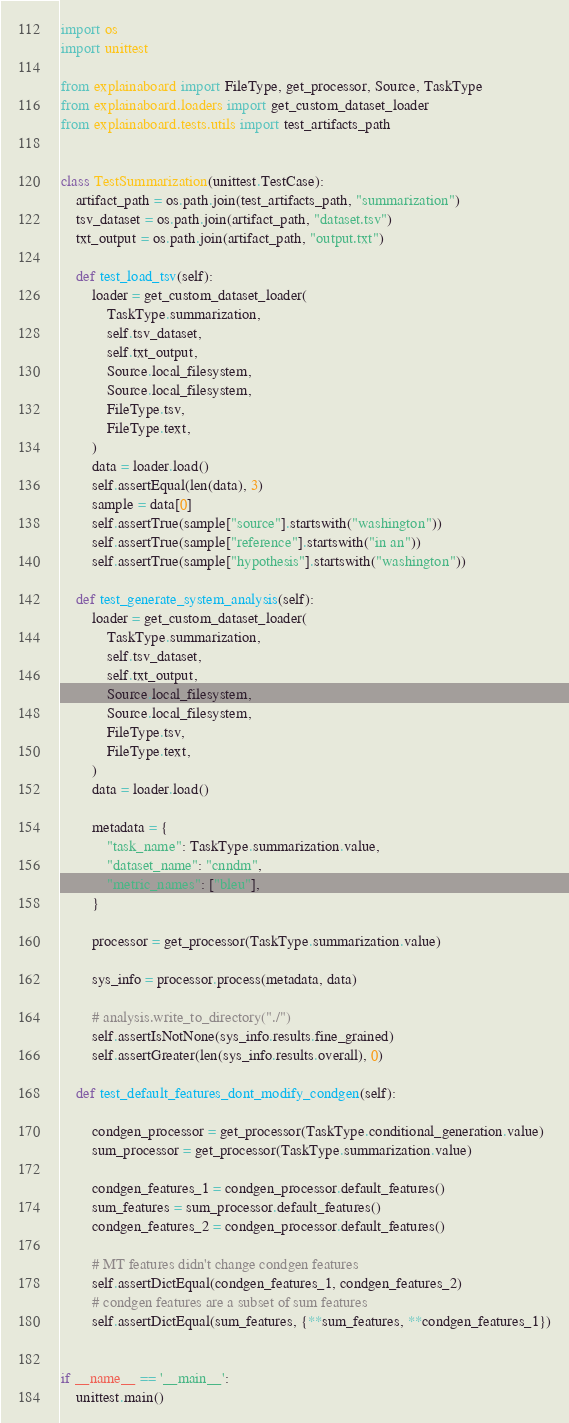Convert code to text. <code><loc_0><loc_0><loc_500><loc_500><_Python_>import os
import unittest

from explainaboard import FileType, get_processor, Source, TaskType
from explainaboard.loaders import get_custom_dataset_loader
from explainaboard.tests.utils import test_artifacts_path


class TestSummarization(unittest.TestCase):
    artifact_path = os.path.join(test_artifacts_path, "summarization")
    tsv_dataset = os.path.join(artifact_path, "dataset.tsv")
    txt_output = os.path.join(artifact_path, "output.txt")

    def test_load_tsv(self):
        loader = get_custom_dataset_loader(
            TaskType.summarization,
            self.tsv_dataset,
            self.txt_output,
            Source.local_filesystem,
            Source.local_filesystem,
            FileType.tsv,
            FileType.text,
        )
        data = loader.load()
        self.assertEqual(len(data), 3)
        sample = data[0]
        self.assertTrue(sample["source"].startswith("washington"))
        self.assertTrue(sample["reference"].startswith("in an"))
        self.assertTrue(sample["hypothesis"].startswith("washington"))

    def test_generate_system_analysis(self):
        loader = get_custom_dataset_loader(
            TaskType.summarization,
            self.tsv_dataset,
            self.txt_output,
            Source.local_filesystem,
            Source.local_filesystem,
            FileType.tsv,
            FileType.text,
        )
        data = loader.load()

        metadata = {
            "task_name": TaskType.summarization.value,
            "dataset_name": "cnndm",
            "metric_names": ["bleu"],
        }

        processor = get_processor(TaskType.summarization.value)

        sys_info = processor.process(metadata, data)

        # analysis.write_to_directory("./")
        self.assertIsNotNone(sys_info.results.fine_grained)
        self.assertGreater(len(sys_info.results.overall), 0)

    def test_default_features_dont_modify_condgen(self):

        condgen_processor = get_processor(TaskType.conditional_generation.value)
        sum_processor = get_processor(TaskType.summarization.value)

        condgen_features_1 = condgen_processor.default_features()
        sum_features = sum_processor.default_features()
        condgen_features_2 = condgen_processor.default_features()

        # MT features didn't change condgen features
        self.assertDictEqual(condgen_features_1, condgen_features_2)
        # condgen features are a subset of sum features
        self.assertDictEqual(sum_features, {**sum_features, **condgen_features_1})


if __name__ == '__main__':
    unittest.main()
</code> 